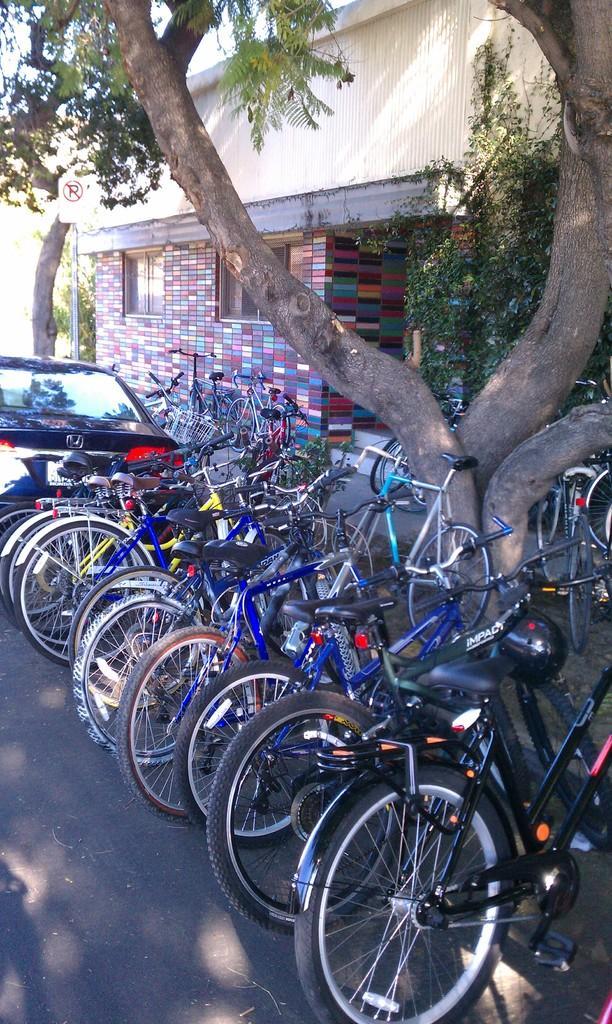Describe this image in one or two sentences. In this image we can see some bicycles, car which are parked, there are some trees and in the background of the image there is a house. 